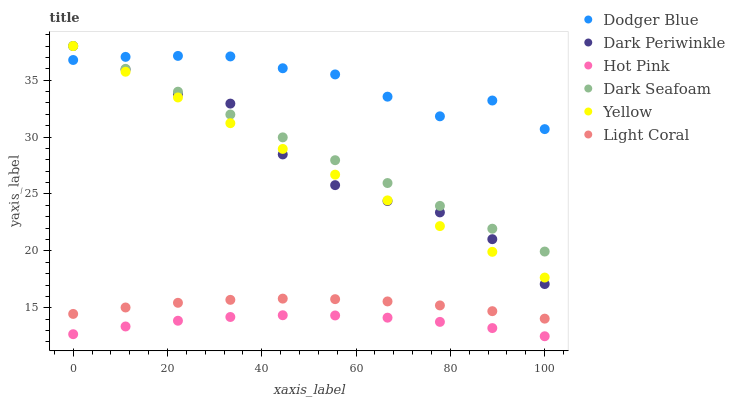Does Hot Pink have the minimum area under the curve?
Answer yes or no. Yes. Does Dodger Blue have the maximum area under the curve?
Answer yes or no. Yes. Does Yellow have the minimum area under the curve?
Answer yes or no. No. Does Yellow have the maximum area under the curve?
Answer yes or no. No. Is Yellow the smoothest?
Answer yes or no. Yes. Is Dark Periwinkle the roughest?
Answer yes or no. Yes. Is Light Coral the smoothest?
Answer yes or no. No. Is Light Coral the roughest?
Answer yes or no. No. Does Hot Pink have the lowest value?
Answer yes or no. Yes. Does Yellow have the lowest value?
Answer yes or no. No. Does Dark Periwinkle have the highest value?
Answer yes or no. Yes. Does Light Coral have the highest value?
Answer yes or no. No. Is Light Coral less than Yellow?
Answer yes or no. Yes. Is Yellow greater than Light Coral?
Answer yes or no. Yes. Does Dark Seafoam intersect Dodger Blue?
Answer yes or no. Yes. Is Dark Seafoam less than Dodger Blue?
Answer yes or no. No. Is Dark Seafoam greater than Dodger Blue?
Answer yes or no. No. Does Light Coral intersect Yellow?
Answer yes or no. No. 